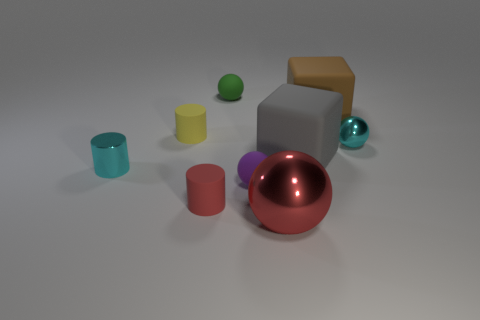Is the color of the tiny shiny cylinder the same as the small shiny sphere?
Provide a succinct answer. Yes. Is the material of the small cyan object that is left of the red matte cylinder the same as the tiny yellow cylinder to the left of the red matte cylinder?
Your answer should be compact. No. What shape is the gray rubber object that is the same size as the red sphere?
Your answer should be compact. Cube. What is the color of the cylinder that is made of the same material as the large ball?
Ensure brevity in your answer.  Cyan. Is the number of cyan spheres left of the brown block less than the number of small red balls?
Provide a succinct answer. No. What is the size of the cube in front of the block that is right of the large block that is in front of the tiny yellow matte cylinder?
Keep it short and to the point. Large. Are the red object to the right of the small green ball and the cyan ball made of the same material?
Give a very brief answer. Yes. What is the material of the ball that is the same color as the shiny cylinder?
Provide a short and direct response. Metal. What number of objects are either small purple matte cylinders or rubber things?
Provide a succinct answer. 6. There is another object that is the same shape as the brown rubber object; what size is it?
Provide a succinct answer. Large. 